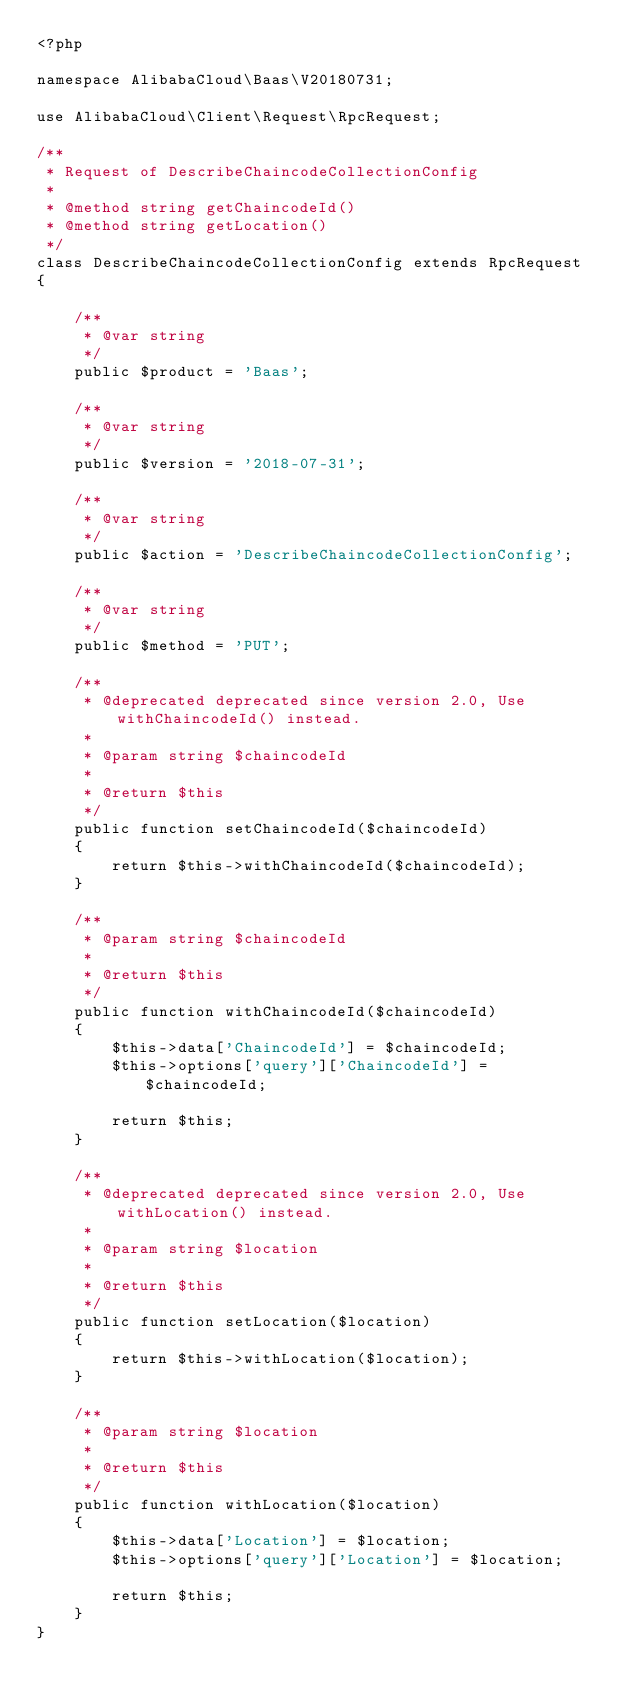Convert code to text. <code><loc_0><loc_0><loc_500><loc_500><_PHP_><?php

namespace AlibabaCloud\Baas\V20180731;

use AlibabaCloud\Client\Request\RpcRequest;

/**
 * Request of DescribeChaincodeCollectionConfig
 *
 * @method string getChaincodeId()
 * @method string getLocation()
 */
class DescribeChaincodeCollectionConfig extends RpcRequest
{

    /**
     * @var string
     */
    public $product = 'Baas';

    /**
     * @var string
     */
    public $version = '2018-07-31';

    /**
     * @var string
     */
    public $action = 'DescribeChaincodeCollectionConfig';

    /**
     * @var string
     */
    public $method = 'PUT';

    /**
     * @deprecated deprecated since version 2.0, Use withChaincodeId() instead.
     *
     * @param string $chaincodeId
     *
     * @return $this
     */
    public function setChaincodeId($chaincodeId)
    {
        return $this->withChaincodeId($chaincodeId);
    }

    /**
     * @param string $chaincodeId
     *
     * @return $this
     */
    public function withChaincodeId($chaincodeId)
    {
        $this->data['ChaincodeId'] = $chaincodeId;
        $this->options['query']['ChaincodeId'] = $chaincodeId;

        return $this;
    }

    /**
     * @deprecated deprecated since version 2.0, Use withLocation() instead.
     *
     * @param string $location
     *
     * @return $this
     */
    public function setLocation($location)
    {
        return $this->withLocation($location);
    }

    /**
     * @param string $location
     *
     * @return $this
     */
    public function withLocation($location)
    {
        $this->data['Location'] = $location;
        $this->options['query']['Location'] = $location;

        return $this;
    }
}
</code> 